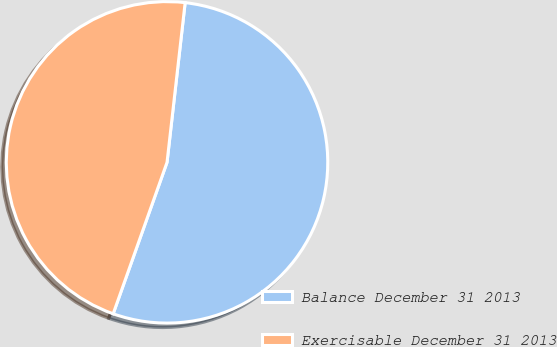Convert chart to OTSL. <chart><loc_0><loc_0><loc_500><loc_500><pie_chart><fcel>Balance December 31 2013<fcel>Exercisable December 31 2013<nl><fcel>53.64%<fcel>46.36%<nl></chart> 